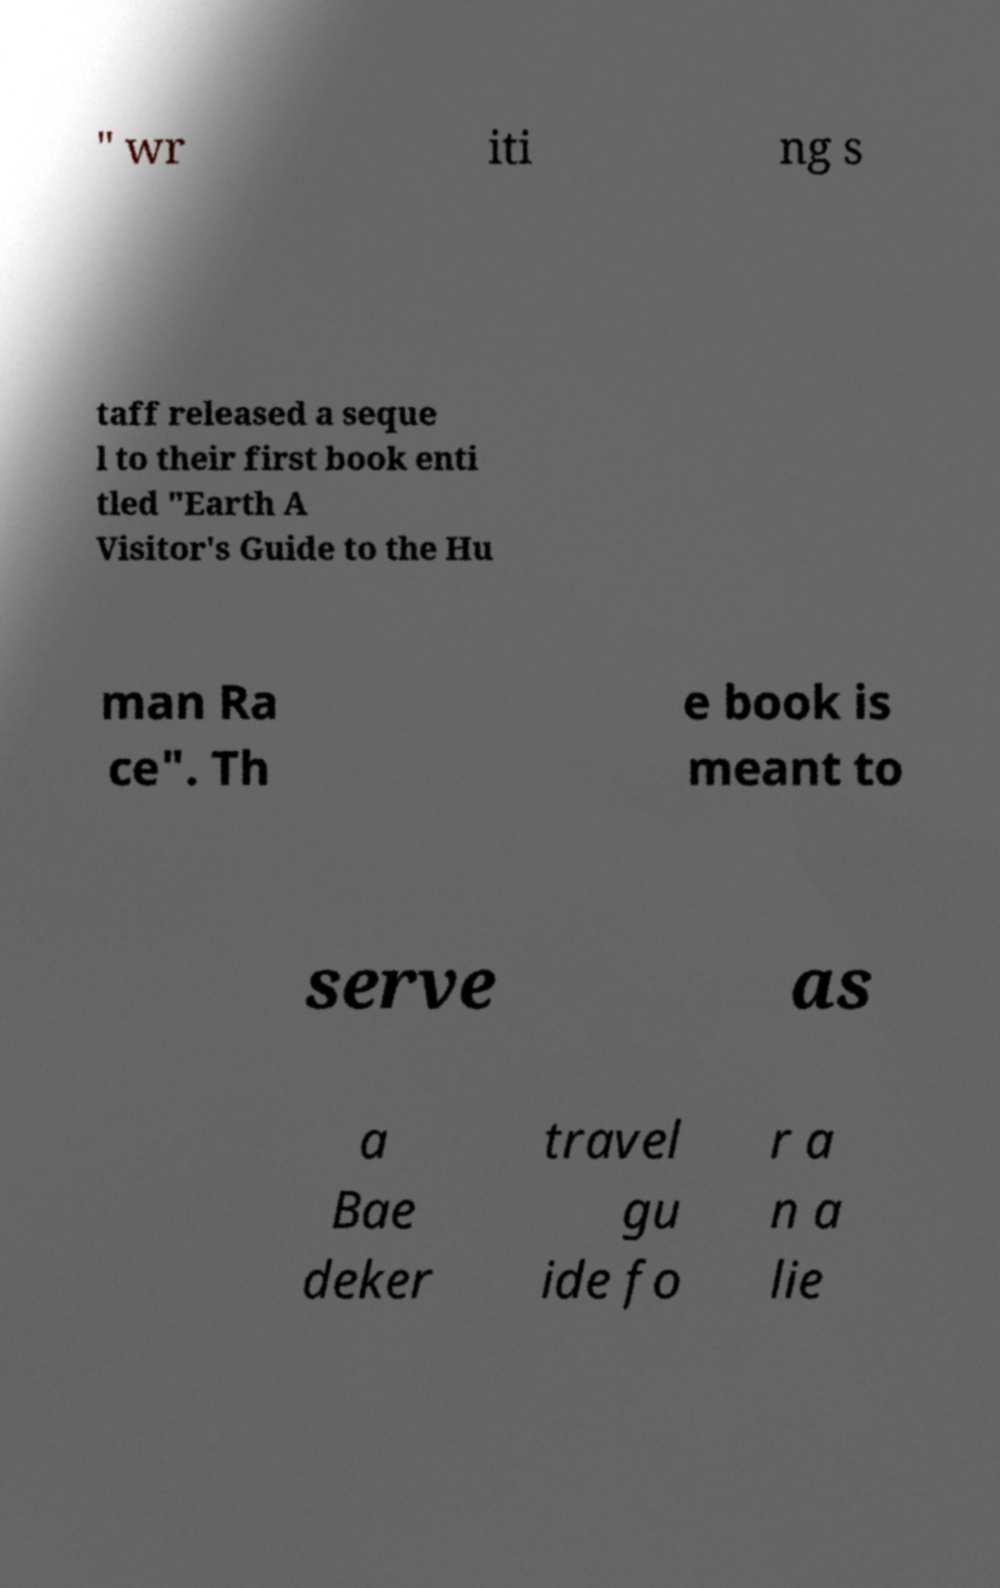Could you extract and type out the text from this image? " wr iti ng s taff released a seque l to their first book enti tled "Earth A Visitor's Guide to the Hu man Ra ce". Th e book is meant to serve as a Bae deker travel gu ide fo r a n a lie 